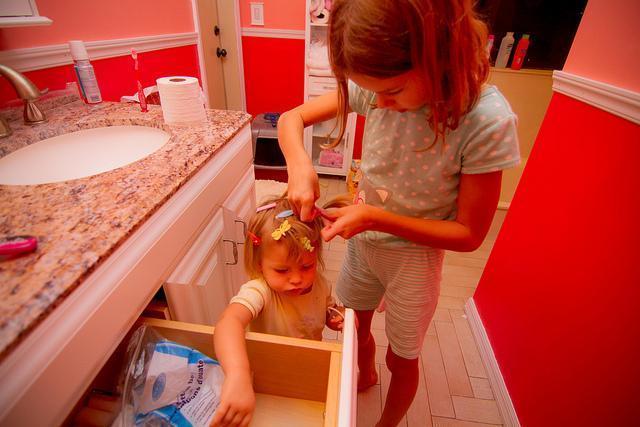How many clips in the little girls hair?
Give a very brief answer. 5. How many people are there?
Give a very brief answer. 2. 